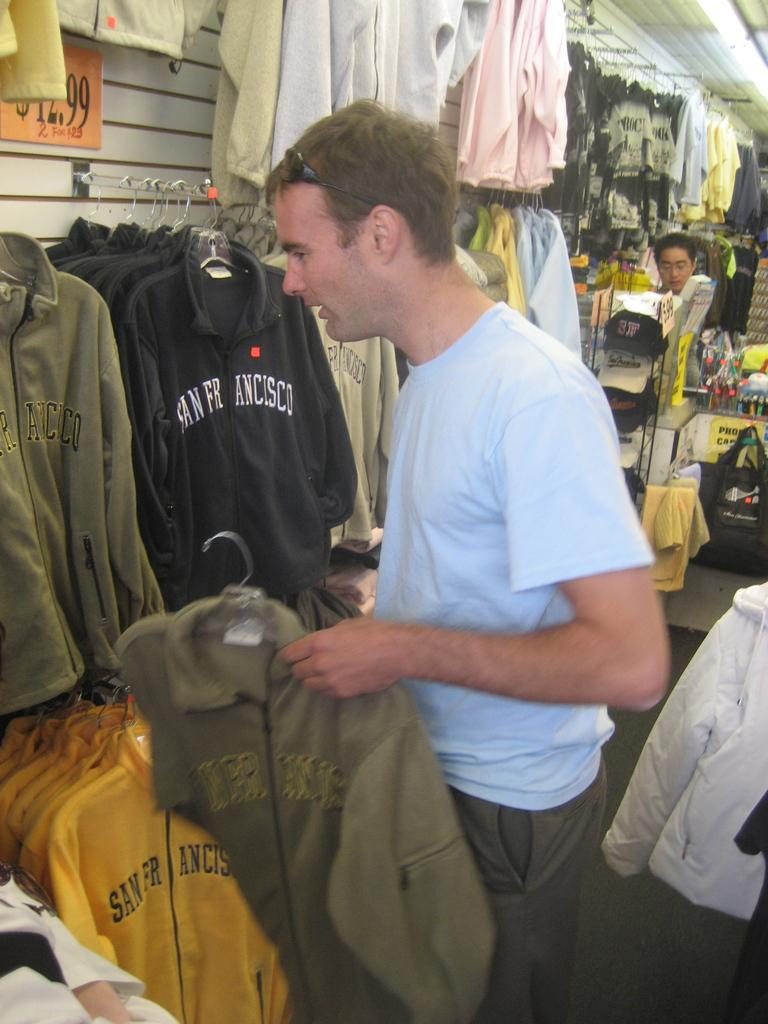Provide a one-sentence caption for the provided image. A man looks through sweatshirts with San Francisco on the front in a store. 